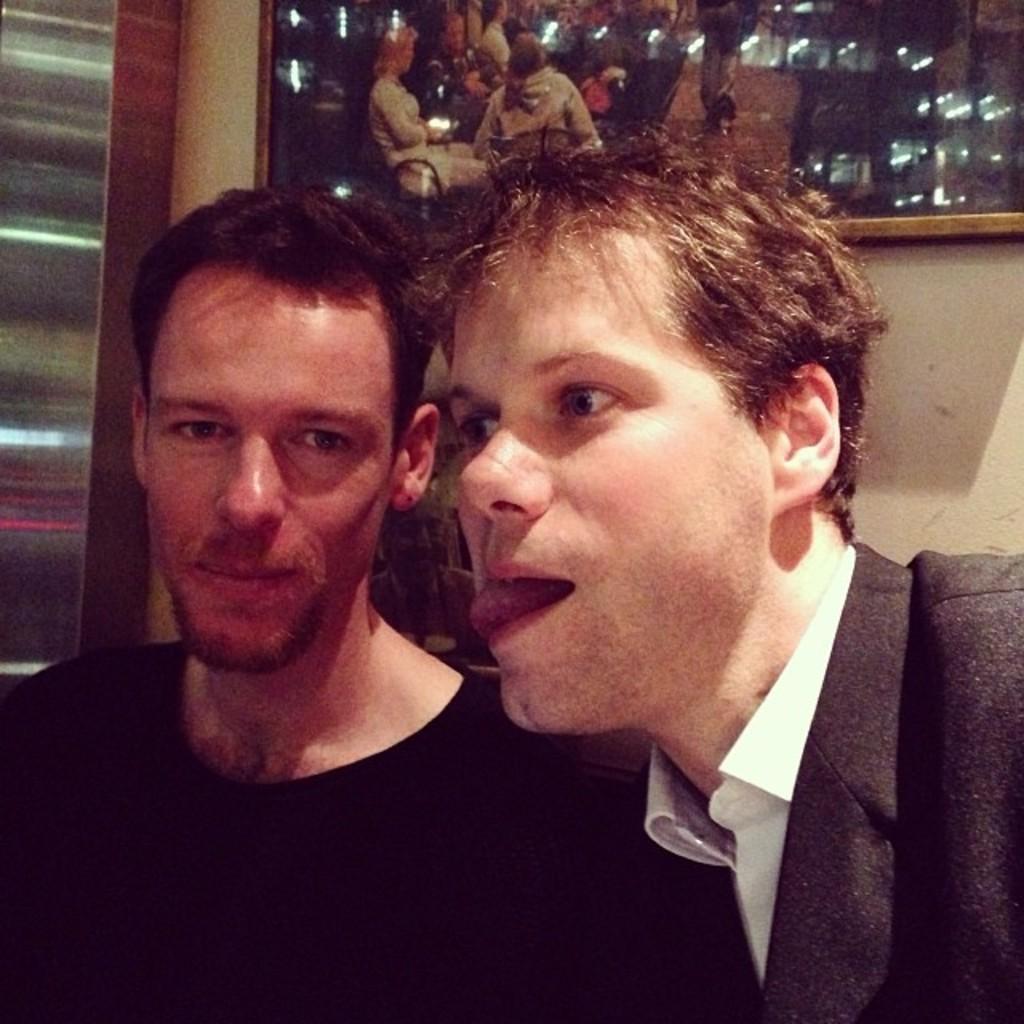Please provide a concise description of this image. In this picture we can see two persons, behind we can see a mirror to the wall. 